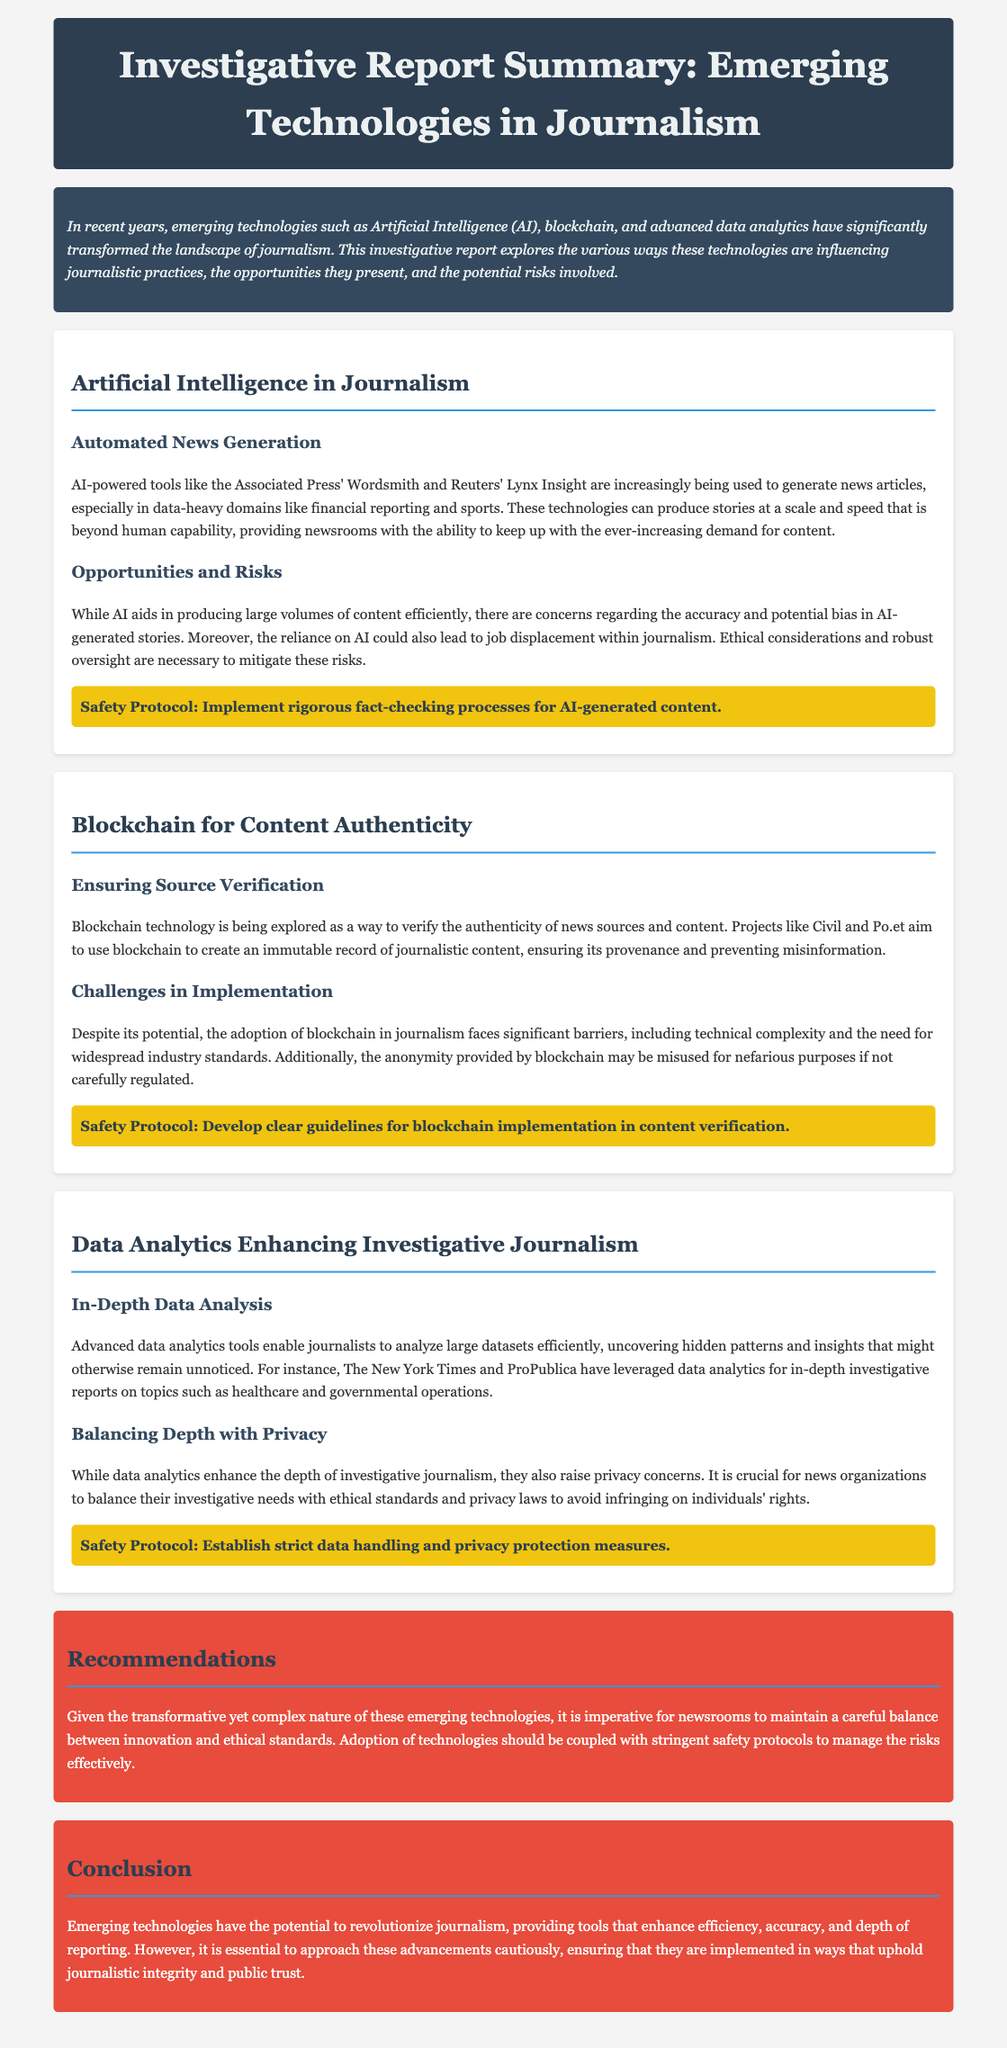What is the main focus of the report? The report explores the impact of emerging technologies like AI, blockchain, and data analytics on journalism.
Answer: Journalism What is an AI-powered tool mentioned in the document? The document mentions AI tools like Wordsmith and Lynx Insight used for automated news generation.
Answer: Wordsmith What is a challenge associated with blockchain in journalism? The document states that blockchain implementation faces significant barriers, including technical complexity.
Answer: Technical complexity What does the section on data analytics emphasize? The section highlights how advanced data analytics enhances depth in investigative journalism by analyzing large datasets.
Answer: In-Depth Data Analysis How should newsrooms balance innovation according to the report? The report recommends that newsrooms should balance innovation with ethical standards and stringent safety protocols.
Answer: Ethical standards What did the report suggest for AI-generated content? The report suggests implementing rigorous fact-checking processes for AI-generated content.
Answer: Fact-checking processes What is the color of the recommendations section in the document? The recommendations section is distinguished by its background color, which is red.
Answer: Red What should be developed for blockchain implementation, as mentioned in the report? The report recommends developing clear guidelines for blockchain implementation in content verification.
Answer: Clear guidelines What is emphasized in the conclusion of the report? The conclusion emphasizes that emerging technologies should uphold journalistic integrity and public trust.
Answer: Journalistic integrity 